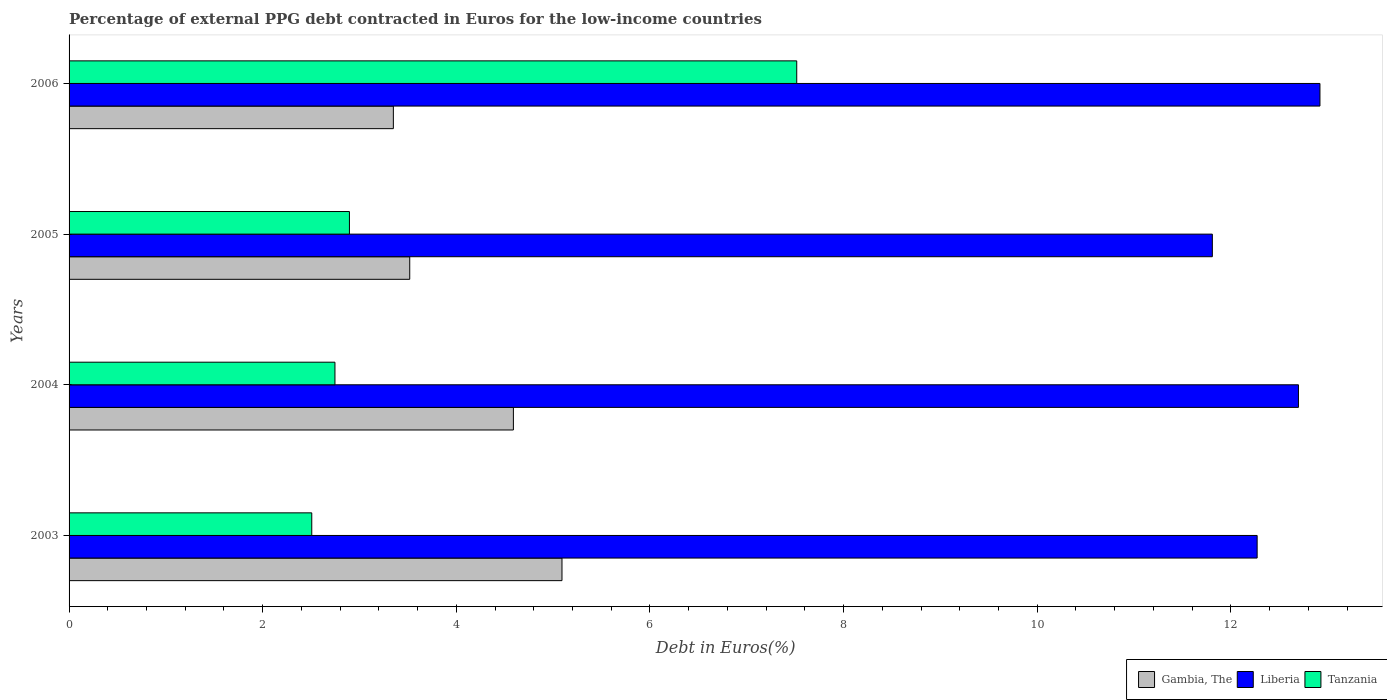How many different coloured bars are there?
Your answer should be very brief. 3. How many groups of bars are there?
Offer a very short reply. 4. Are the number of bars per tick equal to the number of legend labels?
Make the answer very short. Yes. How many bars are there on the 4th tick from the top?
Offer a terse response. 3. How many bars are there on the 2nd tick from the bottom?
Give a very brief answer. 3. In how many cases, is the number of bars for a given year not equal to the number of legend labels?
Your response must be concise. 0. What is the percentage of external PPG debt contracted in Euros in Liberia in 2004?
Offer a very short reply. 12.7. Across all years, what is the maximum percentage of external PPG debt contracted in Euros in Gambia, The?
Offer a terse response. 5.09. Across all years, what is the minimum percentage of external PPG debt contracted in Euros in Liberia?
Give a very brief answer. 11.81. In which year was the percentage of external PPG debt contracted in Euros in Liberia maximum?
Your answer should be compact. 2006. What is the total percentage of external PPG debt contracted in Euros in Liberia in the graph?
Ensure brevity in your answer.  49.7. What is the difference between the percentage of external PPG debt contracted in Euros in Liberia in 2003 and that in 2004?
Offer a terse response. -0.43. What is the difference between the percentage of external PPG debt contracted in Euros in Gambia, The in 2005 and the percentage of external PPG debt contracted in Euros in Tanzania in 2003?
Keep it short and to the point. 1.01. What is the average percentage of external PPG debt contracted in Euros in Tanzania per year?
Offer a terse response. 3.92. In the year 2003, what is the difference between the percentage of external PPG debt contracted in Euros in Liberia and percentage of external PPG debt contracted in Euros in Gambia, The?
Offer a terse response. 7.18. In how many years, is the percentage of external PPG debt contracted in Euros in Tanzania greater than 12.4 %?
Provide a short and direct response. 0. What is the ratio of the percentage of external PPG debt contracted in Euros in Gambia, The in 2005 to that in 2006?
Provide a succinct answer. 1.05. What is the difference between the highest and the second highest percentage of external PPG debt contracted in Euros in Liberia?
Offer a very short reply. 0.22. What is the difference between the highest and the lowest percentage of external PPG debt contracted in Euros in Liberia?
Ensure brevity in your answer.  1.11. In how many years, is the percentage of external PPG debt contracted in Euros in Liberia greater than the average percentage of external PPG debt contracted in Euros in Liberia taken over all years?
Provide a short and direct response. 2. What does the 1st bar from the top in 2003 represents?
Give a very brief answer. Tanzania. What does the 2nd bar from the bottom in 2005 represents?
Give a very brief answer. Liberia. Is it the case that in every year, the sum of the percentage of external PPG debt contracted in Euros in Liberia and percentage of external PPG debt contracted in Euros in Gambia, The is greater than the percentage of external PPG debt contracted in Euros in Tanzania?
Offer a very short reply. Yes. How many bars are there?
Your response must be concise. 12. Are the values on the major ticks of X-axis written in scientific E-notation?
Provide a succinct answer. No. Does the graph contain any zero values?
Make the answer very short. No. How many legend labels are there?
Ensure brevity in your answer.  3. How are the legend labels stacked?
Provide a short and direct response. Horizontal. What is the title of the graph?
Give a very brief answer. Percentage of external PPG debt contracted in Euros for the low-income countries. What is the label or title of the X-axis?
Make the answer very short. Debt in Euros(%). What is the label or title of the Y-axis?
Keep it short and to the point. Years. What is the Debt in Euros(%) in Gambia, The in 2003?
Your answer should be compact. 5.09. What is the Debt in Euros(%) of Liberia in 2003?
Your response must be concise. 12.27. What is the Debt in Euros(%) in Tanzania in 2003?
Provide a succinct answer. 2.51. What is the Debt in Euros(%) in Gambia, The in 2004?
Provide a succinct answer. 4.59. What is the Debt in Euros(%) in Liberia in 2004?
Your response must be concise. 12.7. What is the Debt in Euros(%) of Tanzania in 2004?
Provide a succinct answer. 2.75. What is the Debt in Euros(%) of Gambia, The in 2005?
Your answer should be very brief. 3.52. What is the Debt in Euros(%) in Liberia in 2005?
Give a very brief answer. 11.81. What is the Debt in Euros(%) in Tanzania in 2005?
Ensure brevity in your answer.  2.9. What is the Debt in Euros(%) in Gambia, The in 2006?
Provide a succinct answer. 3.35. What is the Debt in Euros(%) of Liberia in 2006?
Offer a very short reply. 12.92. What is the Debt in Euros(%) in Tanzania in 2006?
Ensure brevity in your answer.  7.52. Across all years, what is the maximum Debt in Euros(%) in Gambia, The?
Offer a terse response. 5.09. Across all years, what is the maximum Debt in Euros(%) of Liberia?
Your answer should be compact. 12.92. Across all years, what is the maximum Debt in Euros(%) in Tanzania?
Keep it short and to the point. 7.52. Across all years, what is the minimum Debt in Euros(%) of Gambia, The?
Keep it short and to the point. 3.35. Across all years, what is the minimum Debt in Euros(%) of Liberia?
Provide a short and direct response. 11.81. Across all years, what is the minimum Debt in Euros(%) in Tanzania?
Provide a succinct answer. 2.51. What is the total Debt in Euros(%) in Gambia, The in the graph?
Ensure brevity in your answer.  16.55. What is the total Debt in Euros(%) in Liberia in the graph?
Your response must be concise. 49.7. What is the total Debt in Euros(%) in Tanzania in the graph?
Provide a short and direct response. 15.67. What is the difference between the Debt in Euros(%) in Gambia, The in 2003 and that in 2004?
Make the answer very short. 0.5. What is the difference between the Debt in Euros(%) in Liberia in 2003 and that in 2004?
Give a very brief answer. -0.43. What is the difference between the Debt in Euros(%) of Tanzania in 2003 and that in 2004?
Provide a succinct answer. -0.24. What is the difference between the Debt in Euros(%) in Gambia, The in 2003 and that in 2005?
Provide a succinct answer. 1.57. What is the difference between the Debt in Euros(%) in Liberia in 2003 and that in 2005?
Keep it short and to the point. 0.46. What is the difference between the Debt in Euros(%) of Tanzania in 2003 and that in 2005?
Offer a very short reply. -0.39. What is the difference between the Debt in Euros(%) of Gambia, The in 2003 and that in 2006?
Make the answer very short. 1.74. What is the difference between the Debt in Euros(%) of Liberia in 2003 and that in 2006?
Give a very brief answer. -0.65. What is the difference between the Debt in Euros(%) of Tanzania in 2003 and that in 2006?
Your response must be concise. -5.01. What is the difference between the Debt in Euros(%) in Gambia, The in 2004 and that in 2005?
Your response must be concise. 1.07. What is the difference between the Debt in Euros(%) in Liberia in 2004 and that in 2005?
Provide a succinct answer. 0.89. What is the difference between the Debt in Euros(%) in Tanzania in 2004 and that in 2005?
Ensure brevity in your answer.  -0.15. What is the difference between the Debt in Euros(%) of Gambia, The in 2004 and that in 2006?
Your answer should be compact. 1.24. What is the difference between the Debt in Euros(%) in Liberia in 2004 and that in 2006?
Offer a terse response. -0.22. What is the difference between the Debt in Euros(%) in Tanzania in 2004 and that in 2006?
Offer a very short reply. -4.77. What is the difference between the Debt in Euros(%) in Gambia, The in 2005 and that in 2006?
Provide a succinct answer. 0.17. What is the difference between the Debt in Euros(%) in Liberia in 2005 and that in 2006?
Ensure brevity in your answer.  -1.11. What is the difference between the Debt in Euros(%) in Tanzania in 2005 and that in 2006?
Your response must be concise. -4.62. What is the difference between the Debt in Euros(%) of Gambia, The in 2003 and the Debt in Euros(%) of Liberia in 2004?
Provide a short and direct response. -7.61. What is the difference between the Debt in Euros(%) of Gambia, The in 2003 and the Debt in Euros(%) of Tanzania in 2004?
Ensure brevity in your answer.  2.35. What is the difference between the Debt in Euros(%) of Liberia in 2003 and the Debt in Euros(%) of Tanzania in 2004?
Give a very brief answer. 9.53. What is the difference between the Debt in Euros(%) in Gambia, The in 2003 and the Debt in Euros(%) in Liberia in 2005?
Your answer should be compact. -6.72. What is the difference between the Debt in Euros(%) of Gambia, The in 2003 and the Debt in Euros(%) of Tanzania in 2005?
Provide a short and direct response. 2.2. What is the difference between the Debt in Euros(%) in Liberia in 2003 and the Debt in Euros(%) in Tanzania in 2005?
Make the answer very short. 9.38. What is the difference between the Debt in Euros(%) in Gambia, The in 2003 and the Debt in Euros(%) in Liberia in 2006?
Offer a very short reply. -7.83. What is the difference between the Debt in Euros(%) in Gambia, The in 2003 and the Debt in Euros(%) in Tanzania in 2006?
Keep it short and to the point. -2.42. What is the difference between the Debt in Euros(%) in Liberia in 2003 and the Debt in Euros(%) in Tanzania in 2006?
Give a very brief answer. 4.76. What is the difference between the Debt in Euros(%) of Gambia, The in 2004 and the Debt in Euros(%) of Liberia in 2005?
Provide a succinct answer. -7.22. What is the difference between the Debt in Euros(%) of Gambia, The in 2004 and the Debt in Euros(%) of Tanzania in 2005?
Give a very brief answer. 1.69. What is the difference between the Debt in Euros(%) of Liberia in 2004 and the Debt in Euros(%) of Tanzania in 2005?
Your answer should be very brief. 9.8. What is the difference between the Debt in Euros(%) of Gambia, The in 2004 and the Debt in Euros(%) of Liberia in 2006?
Your answer should be very brief. -8.33. What is the difference between the Debt in Euros(%) of Gambia, The in 2004 and the Debt in Euros(%) of Tanzania in 2006?
Provide a short and direct response. -2.93. What is the difference between the Debt in Euros(%) in Liberia in 2004 and the Debt in Euros(%) in Tanzania in 2006?
Make the answer very short. 5.18. What is the difference between the Debt in Euros(%) of Gambia, The in 2005 and the Debt in Euros(%) of Liberia in 2006?
Offer a terse response. -9.4. What is the difference between the Debt in Euros(%) of Gambia, The in 2005 and the Debt in Euros(%) of Tanzania in 2006?
Give a very brief answer. -4. What is the difference between the Debt in Euros(%) in Liberia in 2005 and the Debt in Euros(%) in Tanzania in 2006?
Offer a very short reply. 4.29. What is the average Debt in Euros(%) in Gambia, The per year?
Offer a terse response. 4.14. What is the average Debt in Euros(%) in Liberia per year?
Your answer should be very brief. 12.43. What is the average Debt in Euros(%) of Tanzania per year?
Give a very brief answer. 3.92. In the year 2003, what is the difference between the Debt in Euros(%) of Gambia, The and Debt in Euros(%) of Liberia?
Provide a short and direct response. -7.18. In the year 2003, what is the difference between the Debt in Euros(%) in Gambia, The and Debt in Euros(%) in Tanzania?
Your answer should be compact. 2.58. In the year 2003, what is the difference between the Debt in Euros(%) in Liberia and Debt in Euros(%) in Tanzania?
Ensure brevity in your answer.  9.76. In the year 2004, what is the difference between the Debt in Euros(%) in Gambia, The and Debt in Euros(%) in Liberia?
Offer a terse response. -8.11. In the year 2004, what is the difference between the Debt in Euros(%) in Gambia, The and Debt in Euros(%) in Tanzania?
Ensure brevity in your answer.  1.84. In the year 2004, what is the difference between the Debt in Euros(%) of Liberia and Debt in Euros(%) of Tanzania?
Your answer should be compact. 9.95. In the year 2005, what is the difference between the Debt in Euros(%) of Gambia, The and Debt in Euros(%) of Liberia?
Make the answer very short. -8.29. In the year 2005, what is the difference between the Debt in Euros(%) of Gambia, The and Debt in Euros(%) of Tanzania?
Make the answer very short. 0.62. In the year 2005, what is the difference between the Debt in Euros(%) in Liberia and Debt in Euros(%) in Tanzania?
Give a very brief answer. 8.91. In the year 2006, what is the difference between the Debt in Euros(%) in Gambia, The and Debt in Euros(%) in Liberia?
Offer a terse response. -9.57. In the year 2006, what is the difference between the Debt in Euros(%) of Gambia, The and Debt in Euros(%) of Tanzania?
Offer a terse response. -4.17. In the year 2006, what is the difference between the Debt in Euros(%) in Liberia and Debt in Euros(%) in Tanzania?
Ensure brevity in your answer.  5.4. What is the ratio of the Debt in Euros(%) in Gambia, The in 2003 to that in 2004?
Offer a terse response. 1.11. What is the ratio of the Debt in Euros(%) of Liberia in 2003 to that in 2004?
Provide a short and direct response. 0.97. What is the ratio of the Debt in Euros(%) of Tanzania in 2003 to that in 2004?
Provide a succinct answer. 0.91. What is the ratio of the Debt in Euros(%) of Gambia, The in 2003 to that in 2005?
Your response must be concise. 1.45. What is the ratio of the Debt in Euros(%) in Liberia in 2003 to that in 2005?
Offer a very short reply. 1.04. What is the ratio of the Debt in Euros(%) in Tanzania in 2003 to that in 2005?
Offer a terse response. 0.87. What is the ratio of the Debt in Euros(%) in Gambia, The in 2003 to that in 2006?
Keep it short and to the point. 1.52. What is the ratio of the Debt in Euros(%) of Liberia in 2003 to that in 2006?
Offer a terse response. 0.95. What is the ratio of the Debt in Euros(%) in Tanzania in 2003 to that in 2006?
Ensure brevity in your answer.  0.33. What is the ratio of the Debt in Euros(%) in Gambia, The in 2004 to that in 2005?
Provide a succinct answer. 1.3. What is the ratio of the Debt in Euros(%) in Liberia in 2004 to that in 2005?
Provide a short and direct response. 1.08. What is the ratio of the Debt in Euros(%) in Tanzania in 2004 to that in 2005?
Give a very brief answer. 0.95. What is the ratio of the Debt in Euros(%) of Gambia, The in 2004 to that in 2006?
Give a very brief answer. 1.37. What is the ratio of the Debt in Euros(%) of Liberia in 2004 to that in 2006?
Your response must be concise. 0.98. What is the ratio of the Debt in Euros(%) in Tanzania in 2004 to that in 2006?
Keep it short and to the point. 0.37. What is the ratio of the Debt in Euros(%) of Gambia, The in 2005 to that in 2006?
Give a very brief answer. 1.05. What is the ratio of the Debt in Euros(%) in Liberia in 2005 to that in 2006?
Offer a terse response. 0.91. What is the ratio of the Debt in Euros(%) in Tanzania in 2005 to that in 2006?
Your answer should be compact. 0.39. What is the difference between the highest and the second highest Debt in Euros(%) of Gambia, The?
Provide a succinct answer. 0.5. What is the difference between the highest and the second highest Debt in Euros(%) of Liberia?
Your response must be concise. 0.22. What is the difference between the highest and the second highest Debt in Euros(%) of Tanzania?
Ensure brevity in your answer.  4.62. What is the difference between the highest and the lowest Debt in Euros(%) in Gambia, The?
Offer a terse response. 1.74. What is the difference between the highest and the lowest Debt in Euros(%) of Liberia?
Offer a terse response. 1.11. What is the difference between the highest and the lowest Debt in Euros(%) in Tanzania?
Your answer should be very brief. 5.01. 